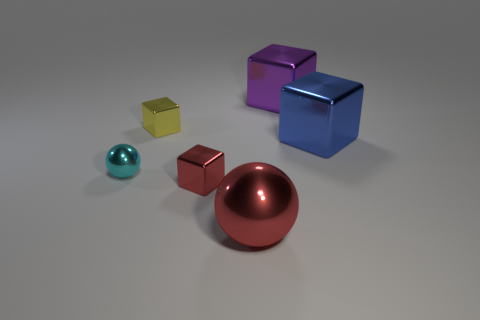How big is the metallic ball on the left side of the large object that is in front of the tiny cyan metal object on the left side of the big metallic ball?
Provide a succinct answer. Small. There is a yellow thing; does it have the same shape as the red metal object that is on the left side of the red sphere?
Ensure brevity in your answer.  Yes. What number of matte things are either large blocks or big purple objects?
Provide a succinct answer. 0. Are there fewer blue shiny objects that are behind the blue object than blue cubes that are behind the cyan metal sphere?
Offer a terse response. Yes. There is a ball behind the metal sphere to the right of the small cyan metallic object; are there any metal balls that are on the right side of it?
Ensure brevity in your answer.  Yes. There is a red metal thing that is to the left of the large sphere; is its shape the same as the small metal object behind the blue object?
Provide a succinct answer. Yes. What is the material of the purple thing that is the same size as the blue block?
Offer a terse response. Metal. Are the big object behind the yellow thing and the big object in front of the tiny cyan metal ball made of the same material?
Provide a short and direct response. Yes. The purple thing that is the same size as the red shiny sphere is what shape?
Give a very brief answer. Cube. What number of other things are there of the same color as the large metal sphere?
Your response must be concise. 1. 